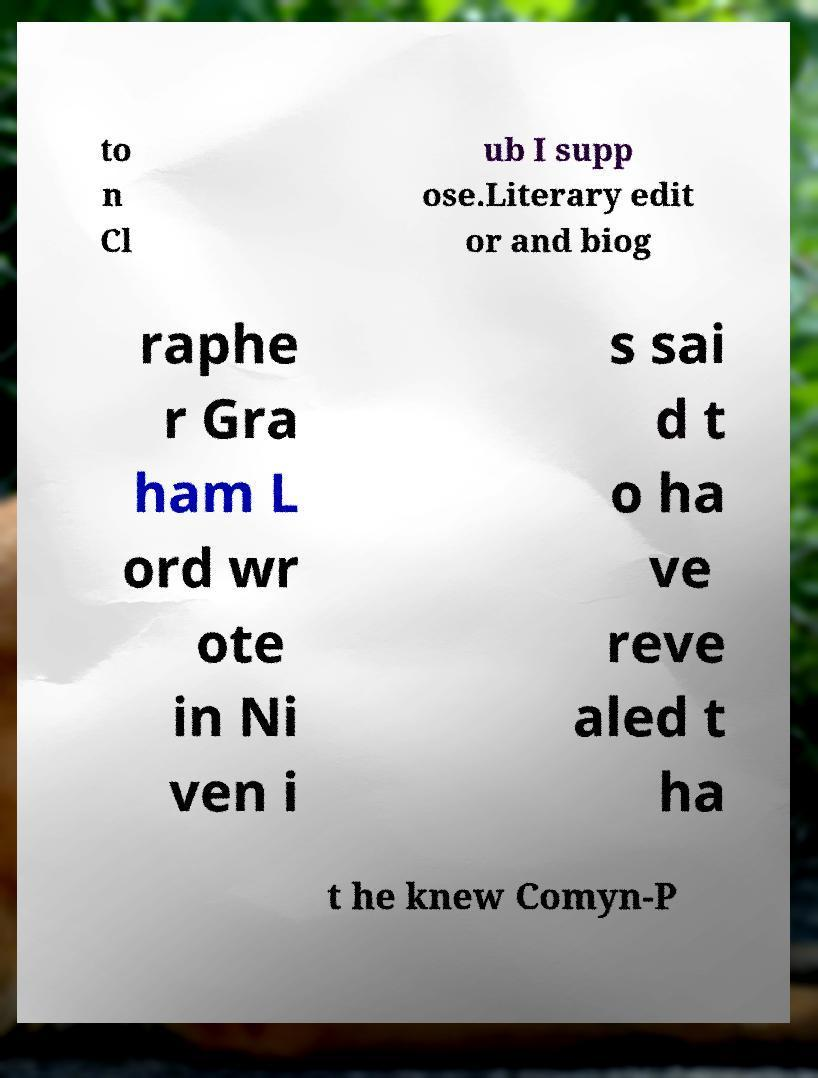Could you extract and type out the text from this image? to n Cl ub I supp ose.Literary edit or and biog raphe r Gra ham L ord wr ote in Ni ven i s sai d t o ha ve reve aled t ha t he knew Comyn-P 